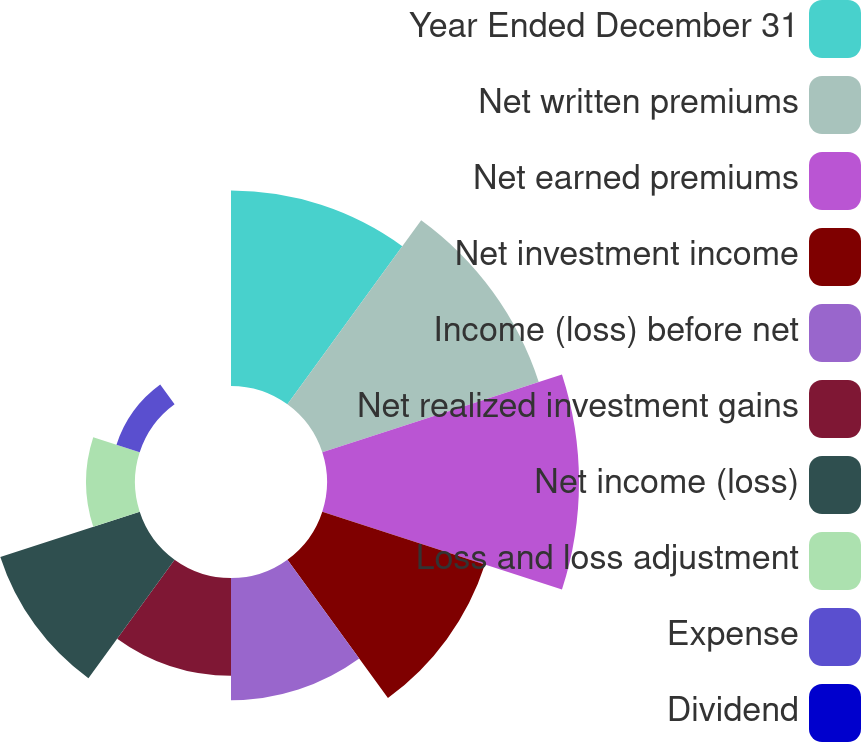<chart> <loc_0><loc_0><loc_500><loc_500><pie_chart><fcel>Year Ended December 31<fcel>Net written premiums<fcel>Net earned premiums<fcel>Net investment income<fcel>Income (loss) before net<fcel>Net realized investment gains<fcel>Net income (loss)<fcel>Loss and loss adjustment<fcel>Expense<fcel>Dividend<nl><fcel>15.2%<fcel>17.7%<fcel>19.6%<fcel>13.3%<fcel>9.5%<fcel>7.6%<fcel>11.4%<fcel>3.8%<fcel>1.9%<fcel>0.0%<nl></chart> 